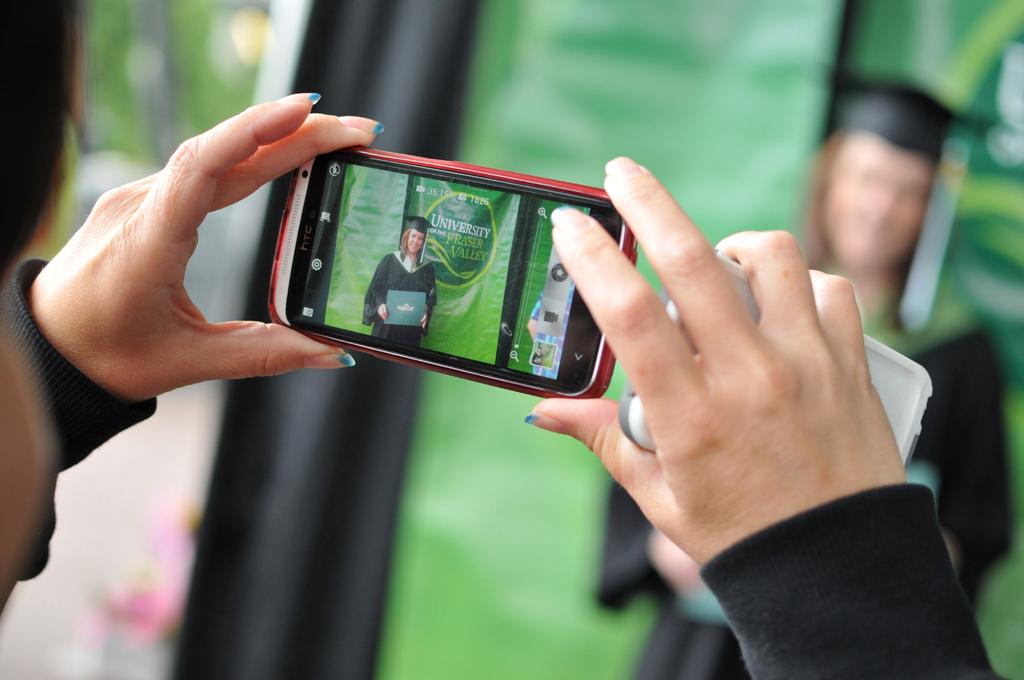Is she graduating from high school or college?
Your answer should be compact. College. Which university it this at?
Keep it short and to the point. Fraser valley. 